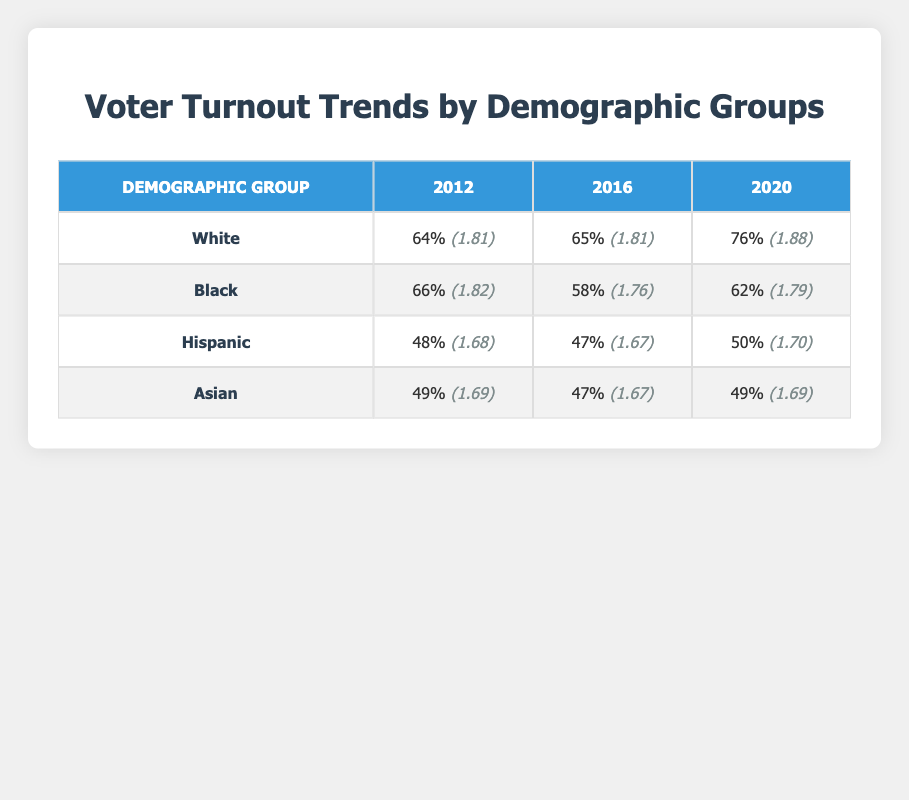What was the voter turnout percentage for Black voters in 2020? The table shows that the turnout percentage for Black voters in the year 2020 is 62.0%.
Answer: 62.0% Which demographic group had the highest voter turnout in 2020? The table indicates that White voters had the highest turnout in 2020 at 76.0%.
Answer: White What was the difference in voter turnout percentage for Hispanic voters between 2016 and 2020? The turnout percentage for Hispanic voters in 2016 is 47.0% and in 2020 it is 50.0%. The difference is calculated as 50.0% - 47.0% = 3.0%.
Answer: 3.0% Is the voter turnout for Asian voters higher in 2012 or 2016? The table shows that Asian voter turnout was 49.0% in 2012 and 47.0% in 2016. Therefore, the turnout was higher in 2012.
Answer: Yes What is the average voter turnout percentage for Black voters across the three elections shown? The percentages for Black voters are 66.0% (2012), 58.0% (2016), and 62.0% (2020). The average is calculated by summing these values (66.0 + 58.0 + 62.0 = 186.0) and dividing by 3, which equals 186.0 / 3 = 62.0%.
Answer: 62.0% 